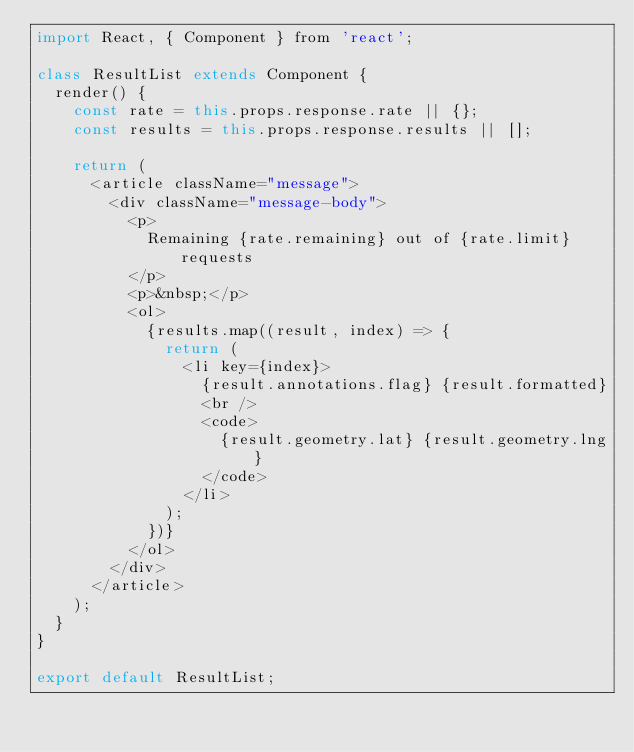Convert code to text. <code><loc_0><loc_0><loc_500><loc_500><_JavaScript_>import React, { Component } from 'react';

class ResultList extends Component {
  render() {
    const rate = this.props.response.rate || {};
    const results = this.props.response.results || [];

    return (
      <article className="message">
        <div className="message-body">
          <p>
            Remaining {rate.remaining} out of {rate.limit} requests
          </p>
          <p>&nbsp;</p>
          <ol>
            {results.map((result, index) => {
              return (
                <li key={index}>
                  {result.annotations.flag} {result.formatted}
                  <br />
                  <code>
                    {result.geometry.lat} {result.geometry.lng}
                  </code>
                </li>
              );
            })}
          </ol>
        </div>
      </article>
    );
  }
}

export default ResultList;
</code> 